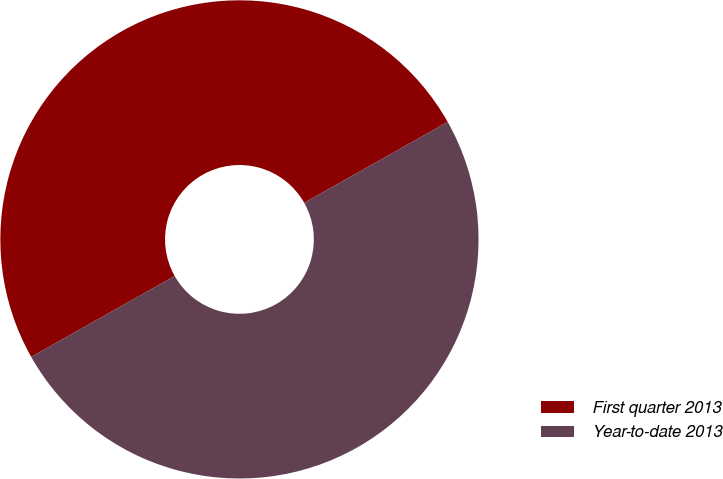Convert chart to OTSL. <chart><loc_0><loc_0><loc_500><loc_500><pie_chart><fcel>First quarter 2013<fcel>Year-to-date 2013<nl><fcel>50.0%<fcel>50.0%<nl></chart> 